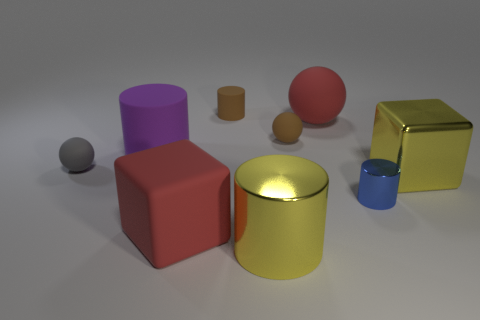Can you discuss the arrangement of shapes and colors in this image and how it might impact the viewer's perception? The grouping of geometric shapes and their varied colors creates a harmonious yet dynamic composition. The cool and warm colors are balanced in a way that draws the eye across the scene. The playful arrangement of sizes, where similar shapes are presented in different scales, adds a sense of proportion and depth, potentially evoking a sense of curiosity about the objects' relationships to one another. 